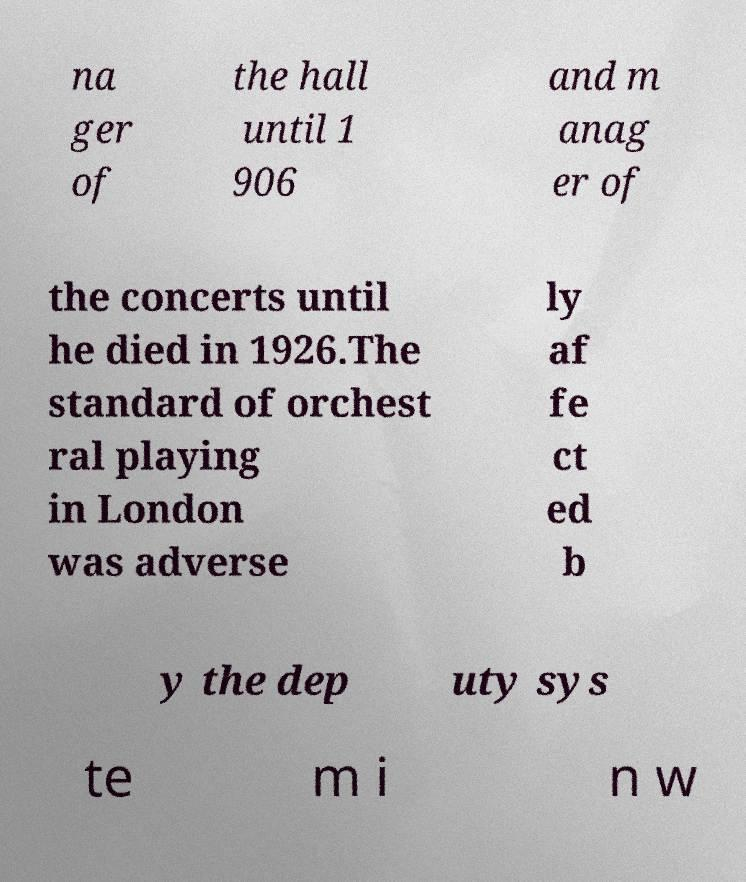Can you read and provide the text displayed in the image?This photo seems to have some interesting text. Can you extract and type it out for me? na ger of the hall until 1 906 and m anag er of the concerts until he died in 1926.The standard of orchest ral playing in London was adverse ly af fe ct ed b y the dep uty sys te m i n w 